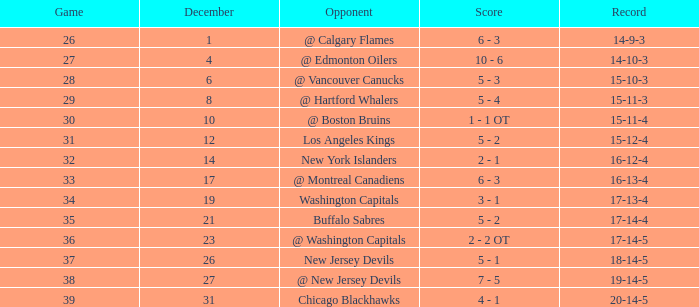Game below 34, and a december below 14, and a score of 10 - 6 has what rival? @ Edmonton Oilers. Help me parse the entirety of this table. {'header': ['Game', 'December', 'Opponent', 'Score', 'Record'], 'rows': [['26', '1', '@ Calgary Flames', '6 - 3', '14-9-3'], ['27', '4', '@ Edmonton Oilers', '10 - 6', '14-10-3'], ['28', '6', '@ Vancouver Canucks', '5 - 3', '15-10-3'], ['29', '8', '@ Hartford Whalers', '5 - 4', '15-11-3'], ['30', '10', '@ Boston Bruins', '1 - 1 OT', '15-11-4'], ['31', '12', 'Los Angeles Kings', '5 - 2', '15-12-4'], ['32', '14', 'New York Islanders', '2 - 1', '16-12-4'], ['33', '17', '@ Montreal Canadiens', '6 - 3', '16-13-4'], ['34', '19', 'Washington Capitals', '3 - 1', '17-13-4'], ['35', '21', 'Buffalo Sabres', '5 - 2', '17-14-4'], ['36', '23', '@ Washington Capitals', '2 - 2 OT', '17-14-5'], ['37', '26', 'New Jersey Devils', '5 - 1', '18-14-5'], ['38', '27', '@ New Jersey Devils', '7 - 5', '19-14-5'], ['39', '31', 'Chicago Blackhawks', '4 - 1', '20-14-5']]} 